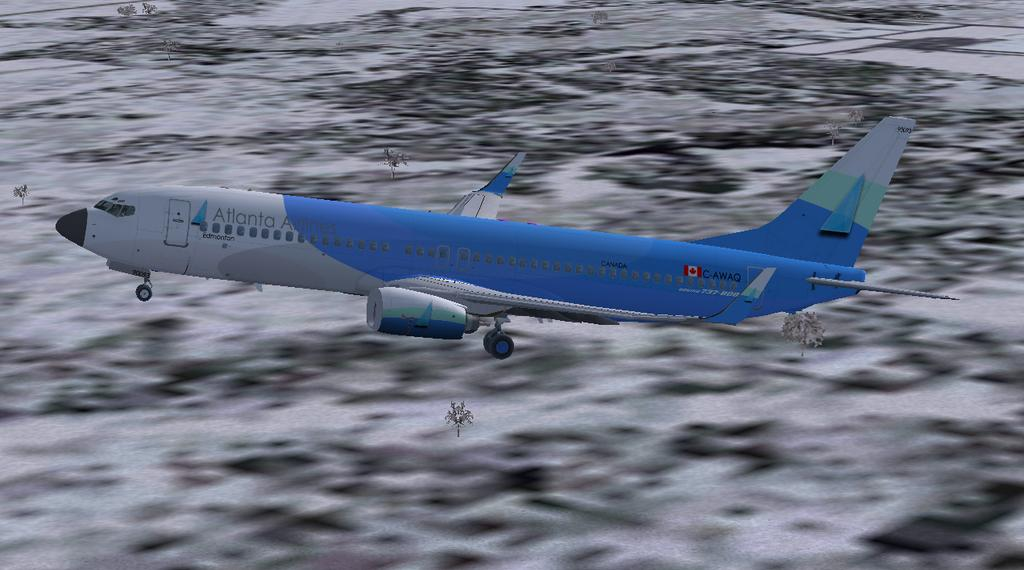What is the main subject of the image? The main subject of the image is an airplane. In which direction is the airplane flying? The airplane is flying towards the left side. Can you describe the background of the image? The background of the image is blurred. What type of committee can be seen meeting in the playground in the image? There is no committee or playground present in the image; it features an airplane flying towards the left side with a blurred background. 